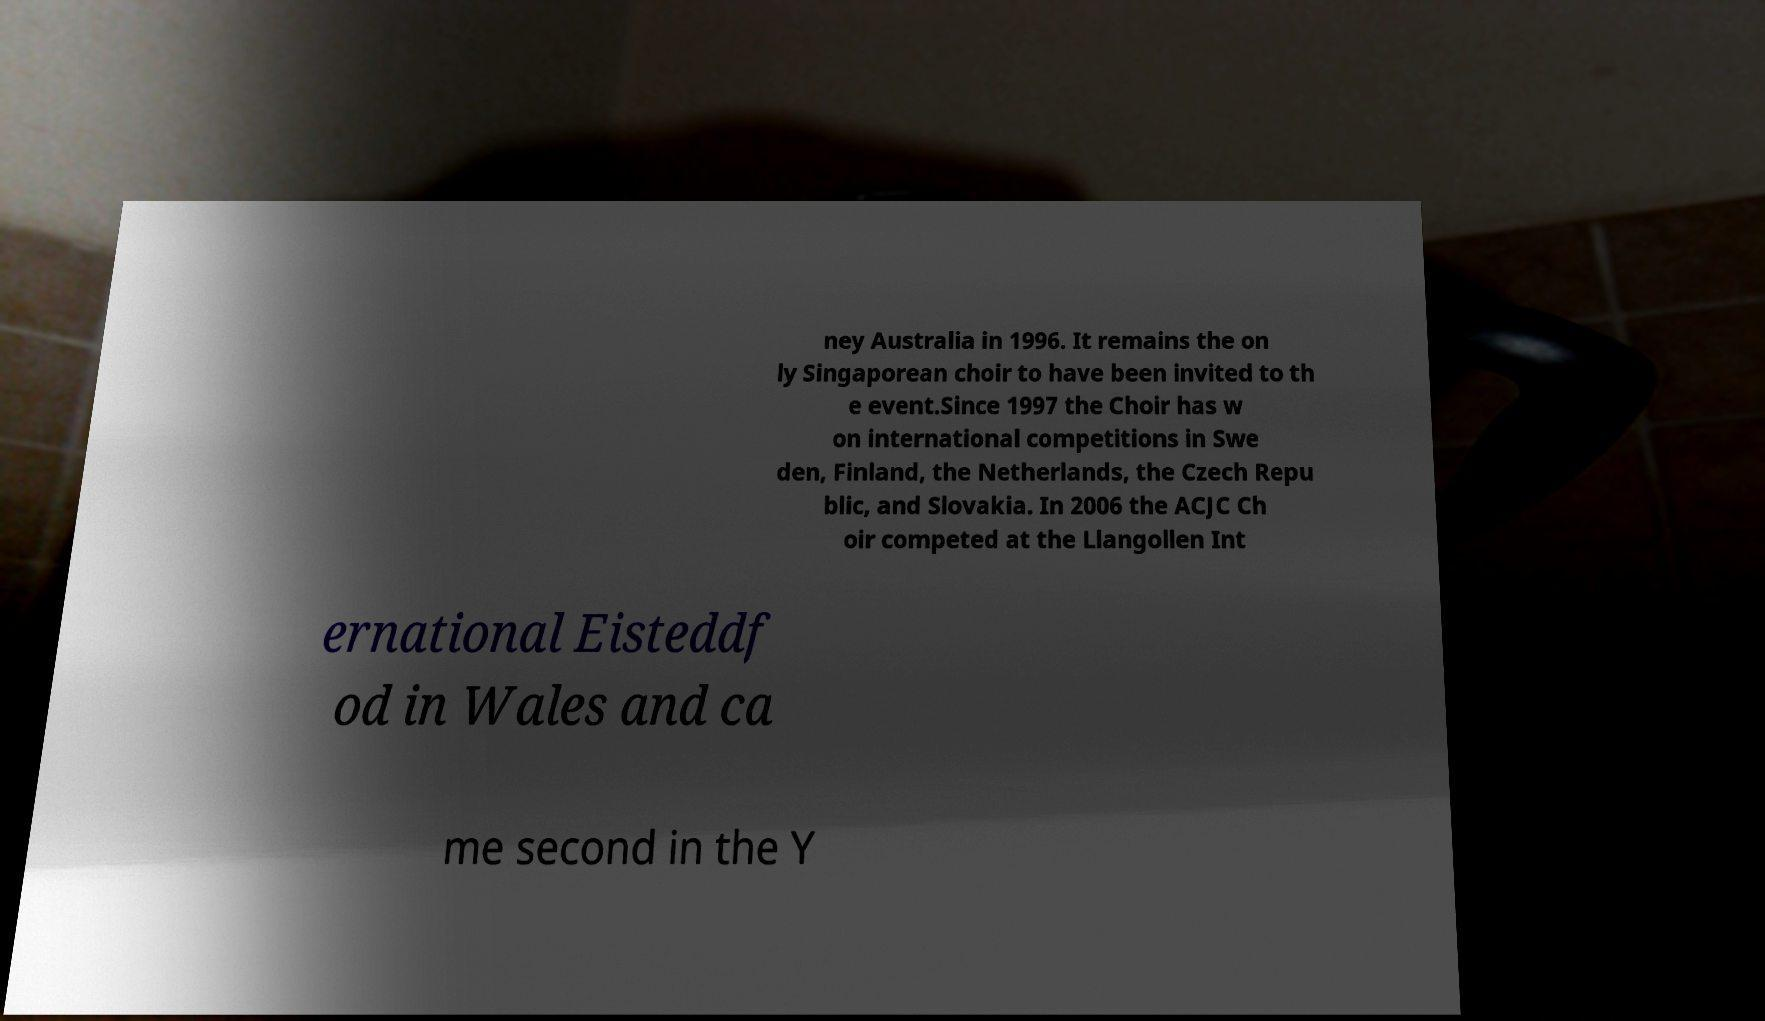Can you accurately transcribe the text from the provided image for me? ney Australia in 1996. It remains the on ly Singaporean choir to have been invited to th e event.Since 1997 the Choir has w on international competitions in Swe den, Finland, the Netherlands, the Czech Repu blic, and Slovakia. In 2006 the ACJC Ch oir competed at the Llangollen Int ernational Eisteddf od in Wales and ca me second in the Y 